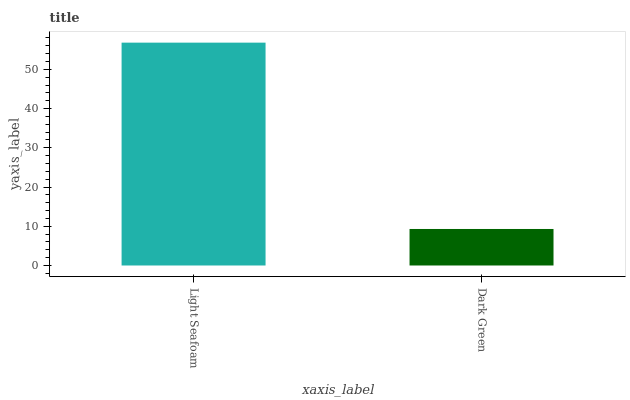Is Dark Green the minimum?
Answer yes or no. Yes. Is Light Seafoam the maximum?
Answer yes or no. Yes. Is Dark Green the maximum?
Answer yes or no. No. Is Light Seafoam greater than Dark Green?
Answer yes or no. Yes. Is Dark Green less than Light Seafoam?
Answer yes or no. Yes. Is Dark Green greater than Light Seafoam?
Answer yes or no. No. Is Light Seafoam less than Dark Green?
Answer yes or no. No. Is Light Seafoam the high median?
Answer yes or no. Yes. Is Dark Green the low median?
Answer yes or no. Yes. Is Dark Green the high median?
Answer yes or no. No. Is Light Seafoam the low median?
Answer yes or no. No. 